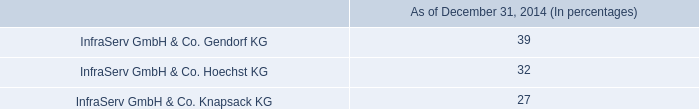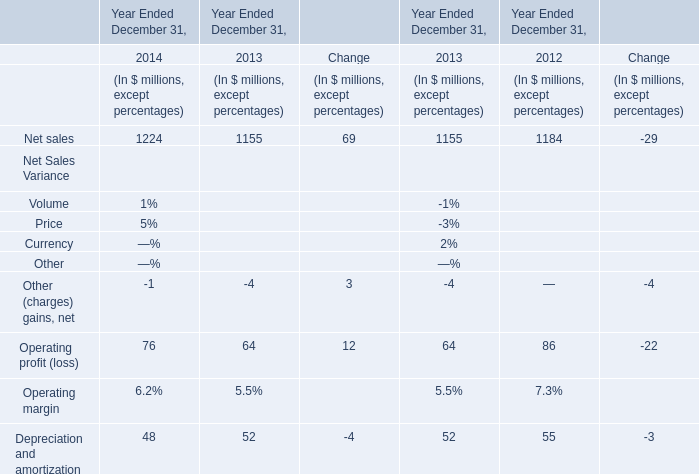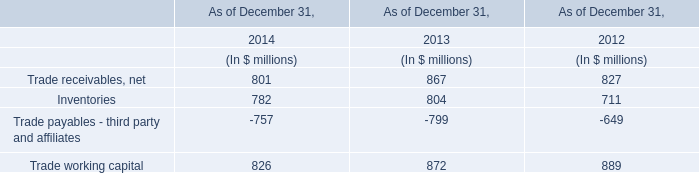Which year is Operating profit (loss) greater than 80? 
Answer: 2012. 